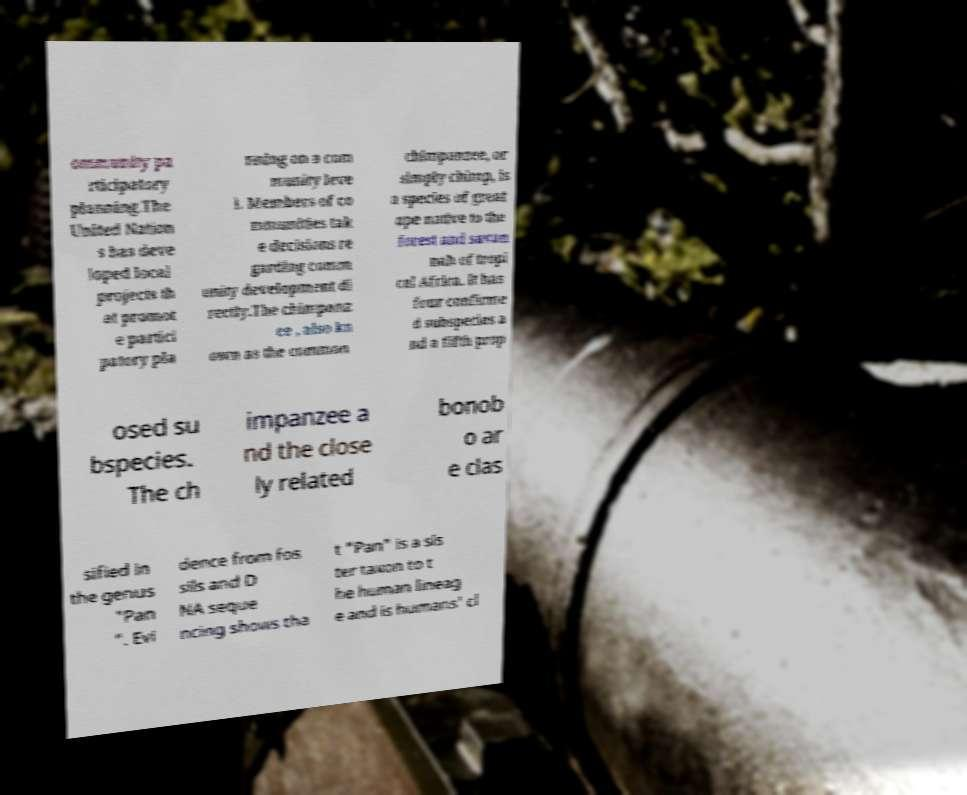Please read and relay the text visible in this image. What does it say? ommunity pa rticipatory planning.The United Nation s has deve loped local projects th at promot e partici patory pla nning on a com munity leve l. Members of co mmunities tak e decisions re garding comm unity development di rectly.The chimpanz ee , also kn own as the common chimpanzee, or simply chimp, is a species of great ape native to the forest and savan nah of tropi cal Africa. It has four confirme d subspecies a nd a fifth prop osed su bspecies. The ch impanzee a nd the close ly related bonob o ar e clas sified in the genus "Pan ". Evi dence from fos sils and D NA seque ncing shows tha t "Pan" is a sis ter taxon to t he human lineag e and is humans' cl 